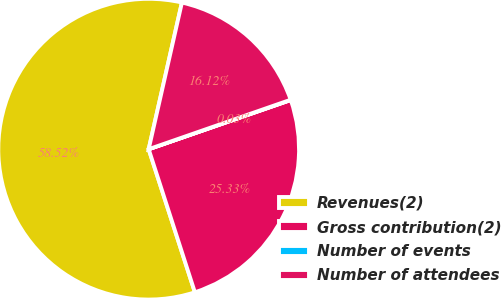<chart> <loc_0><loc_0><loc_500><loc_500><pie_chart><fcel>Revenues(2)<fcel>Gross contribution(2)<fcel>Number of events<fcel>Number of attendees<nl><fcel>58.52%<fcel>25.33%<fcel>0.03%<fcel>16.12%<nl></chart> 